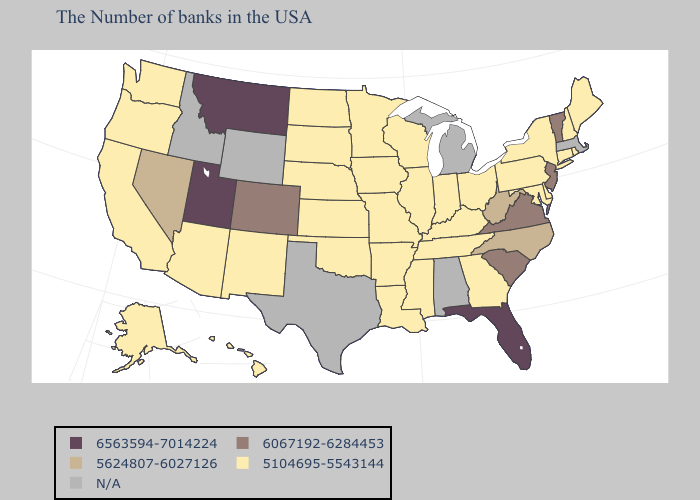What is the highest value in states that border Utah?
Give a very brief answer. 6067192-6284453. What is the value of Oregon?
Quick response, please. 5104695-5543144. What is the lowest value in the West?
Be succinct. 5104695-5543144. Among the states that border Delaware , does Pennsylvania have the highest value?
Concise answer only. No. Name the states that have a value in the range 6067192-6284453?
Quick response, please. Vermont, New Jersey, Virginia, South Carolina, Colorado. Name the states that have a value in the range 6563594-7014224?
Be succinct. Florida, Utah, Montana. Does Arizona have the lowest value in the West?
Be succinct. Yes. Does the map have missing data?
Give a very brief answer. Yes. Does Utah have the highest value in the USA?
Be succinct. Yes. What is the value of Florida?
Answer briefly. 6563594-7014224. What is the lowest value in the South?
Answer briefly. 5104695-5543144. Which states have the lowest value in the USA?
Keep it brief. Maine, Rhode Island, New Hampshire, Connecticut, New York, Delaware, Maryland, Pennsylvania, Ohio, Georgia, Kentucky, Indiana, Tennessee, Wisconsin, Illinois, Mississippi, Louisiana, Missouri, Arkansas, Minnesota, Iowa, Kansas, Nebraska, Oklahoma, South Dakota, North Dakota, New Mexico, Arizona, California, Washington, Oregon, Alaska, Hawaii. Does New York have the lowest value in the Northeast?
Give a very brief answer. Yes. What is the value of Wisconsin?
Give a very brief answer. 5104695-5543144. 